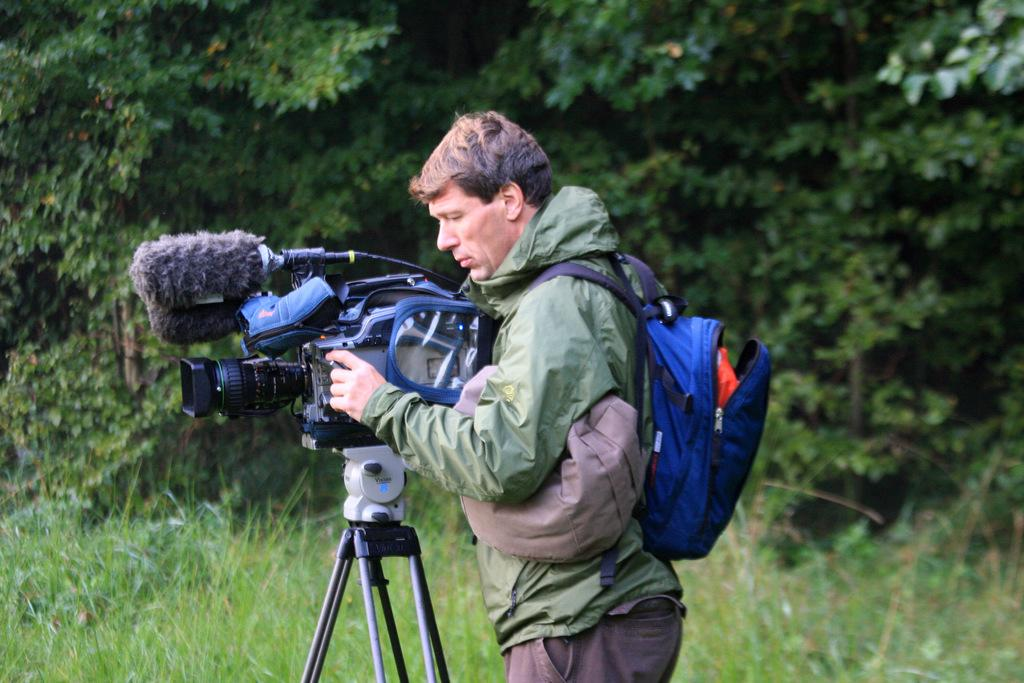Who is the main subject in the image? There is a man in the center of the image. What is the man wearing? The man is wearing a bag. What is the man holding in the image? The man is holding a camera. What can be seen in the background of the image? There are trees and grass in the background of the image. How many zebras can be seen grazing in the grass in the image? There are no zebras present in the image; it features a man holding a camera and a background with trees and grass. 